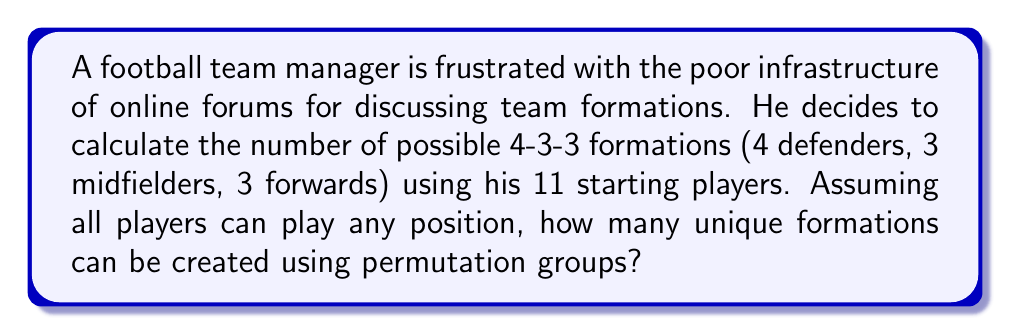Give your solution to this math problem. To solve this problem, we'll use the concept of permutation groups and the multiplication principle.

1) First, we need to consider the structure of a 4-3-3 formation:
   - 4 defenders
   - 3 midfielders
   - 3 forwards
   - 1 goalkeeper (always in the same position)

2) We can treat this as a permutation problem where we're selecting players for each position group.

3) For the goalkeeper, there's no choice to make as their position is fixed. So we start with the outfield players.

4) We have 10 outfield players to distribute among the three position groups:

   a) Choose 4 defenders from 10 players: $\binom{10}{4}$
   b) Choose 3 midfielders from remaining 6 players: $\binom{6}{3}$
   c) The last 3 players automatically become forwards

5) Within each position group, the players can be arranged in any order. This gives us:
   - 4! ways to arrange the defenders
   - 3! ways to arrange the midfielders
   - 3! ways to arrange the forwards

6) Using the multiplication principle, the total number of unique formations is:

   $$ \binom{10}{4} \cdot \binom{6}{3} \cdot 4! \cdot 3! \cdot 3! $$

7) Let's calculate each part:
   $\binom{10}{4} = 210$
   $\binom{6}{3} = 20$
   $4! = 24$
   $3! = 6$

8) Multiplying these together:

   $$ 210 \cdot 20 \cdot 24 \cdot 6 \cdot 6 = 3,628,800 $$

Therefore, there are 3,628,800 possible unique 4-3-3 formations.
Answer: 3,628,800 unique formations 